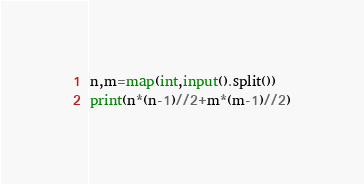<code> <loc_0><loc_0><loc_500><loc_500><_Python_>n,m=map(int,input().split())
print(n*(n-1)//2+m*(m-1)//2)</code> 